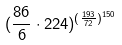<formula> <loc_0><loc_0><loc_500><loc_500>( \frac { 8 6 } { 6 } \cdot 2 2 4 ) ^ { ( \frac { 1 9 3 } { 7 2 } ) ^ { 1 5 0 } }</formula> 